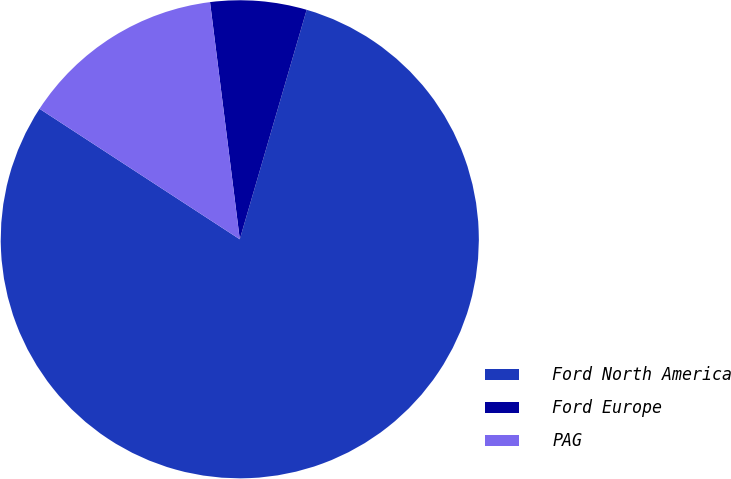Convert chart. <chart><loc_0><loc_0><loc_500><loc_500><pie_chart><fcel>Ford North America<fcel>Ford Europe<fcel>PAG<nl><fcel>79.67%<fcel>6.5%<fcel>13.82%<nl></chart> 